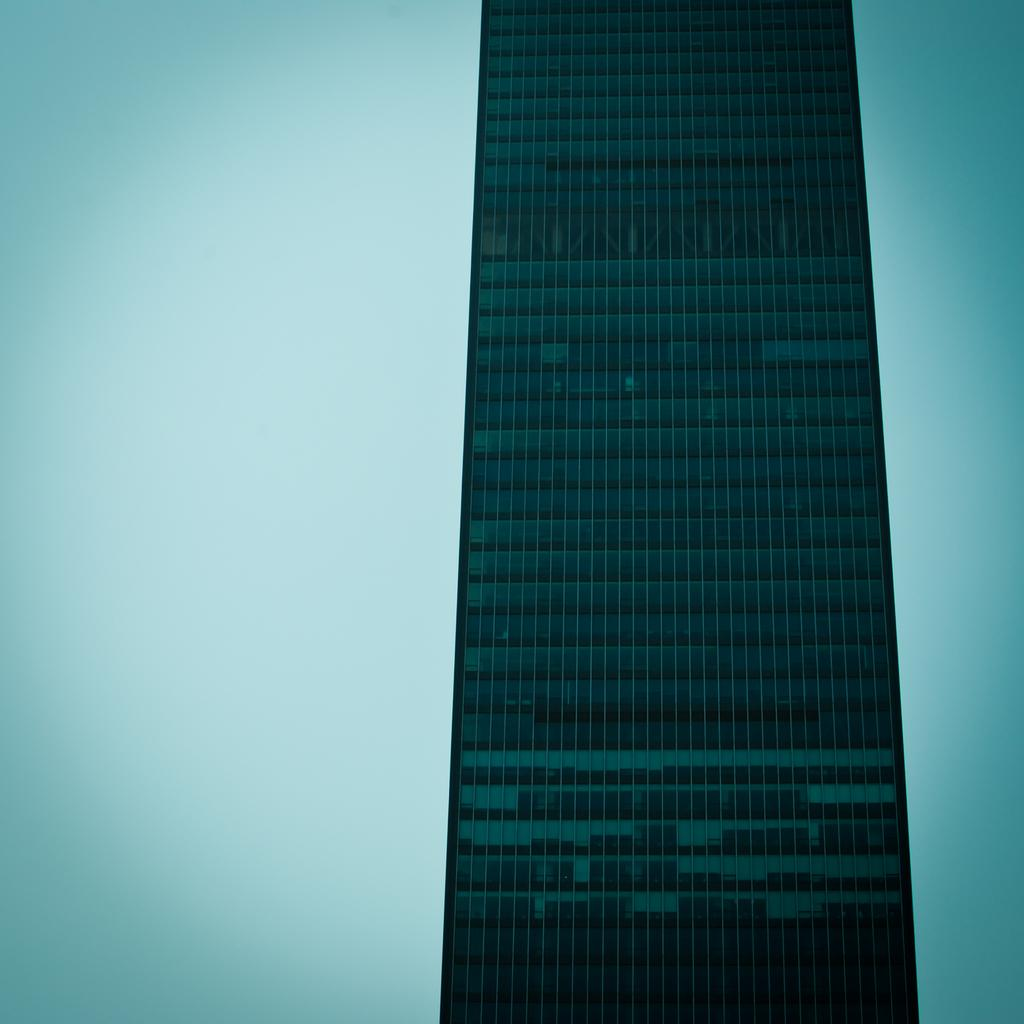What type of structure can be seen in the image? There is a building in the image. How many snakes are sitting on the sofa in the image? There are no snakes or sofas present in the image; it only features a building. 